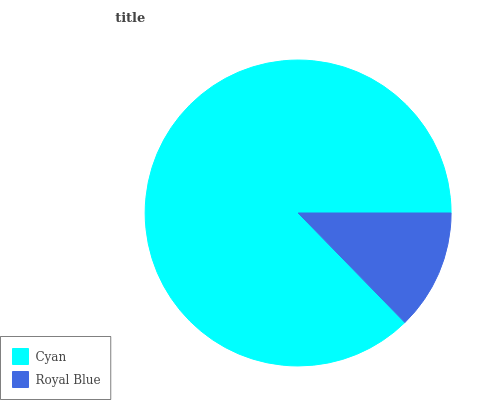Is Royal Blue the minimum?
Answer yes or no. Yes. Is Cyan the maximum?
Answer yes or no. Yes. Is Royal Blue the maximum?
Answer yes or no. No. Is Cyan greater than Royal Blue?
Answer yes or no. Yes. Is Royal Blue less than Cyan?
Answer yes or no. Yes. Is Royal Blue greater than Cyan?
Answer yes or no. No. Is Cyan less than Royal Blue?
Answer yes or no. No. Is Cyan the high median?
Answer yes or no. Yes. Is Royal Blue the low median?
Answer yes or no. Yes. Is Royal Blue the high median?
Answer yes or no. No. Is Cyan the low median?
Answer yes or no. No. 